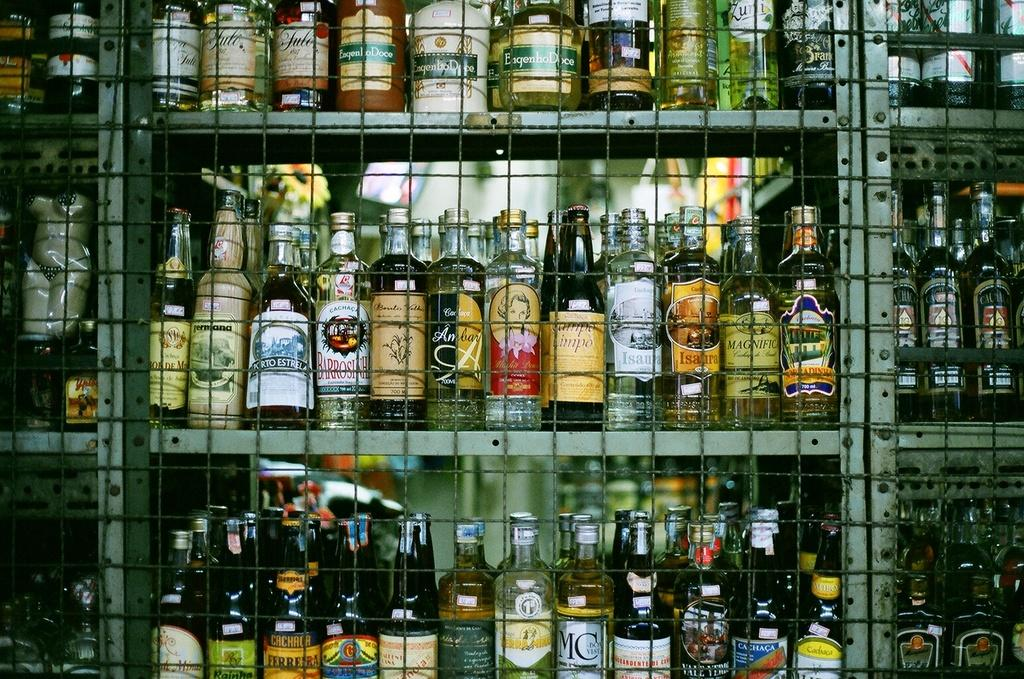<image>
Offer a succinct explanation of the picture presented. Many beer bottles behind a fence including a bottle of Campo Limpo. 